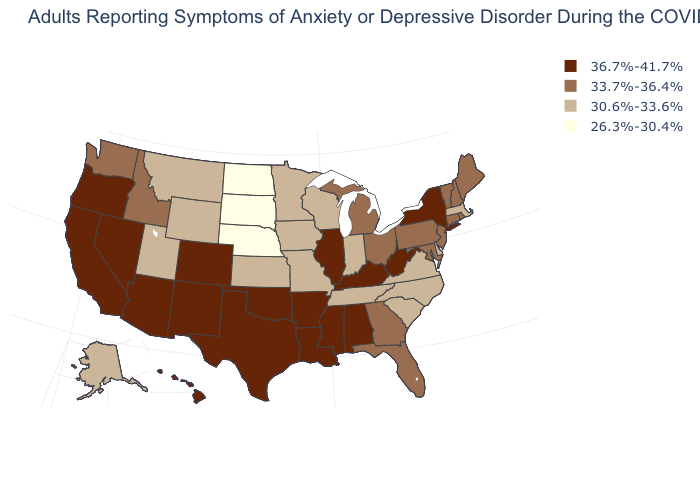What is the lowest value in states that border Massachusetts?
Be succinct. 33.7%-36.4%. What is the value of Minnesota?
Answer briefly. 30.6%-33.6%. What is the value of Minnesota?
Quick response, please. 30.6%-33.6%. What is the value of Kentucky?
Keep it brief. 36.7%-41.7%. Name the states that have a value in the range 36.7%-41.7%?
Give a very brief answer. Alabama, Arizona, Arkansas, California, Colorado, Hawaii, Illinois, Kentucky, Louisiana, Mississippi, Nevada, New Mexico, New York, Oklahoma, Oregon, Texas, West Virginia. Among the states that border Alabama , which have the highest value?
Short answer required. Mississippi. Name the states that have a value in the range 33.7%-36.4%?
Quick response, please. Connecticut, Florida, Georgia, Idaho, Maine, Maryland, Michigan, New Hampshire, New Jersey, Ohio, Pennsylvania, Rhode Island, Vermont, Washington. Among the states that border Pennsylvania , which have the highest value?
Quick response, please. New York, West Virginia. Does Utah have the lowest value in the West?
Concise answer only. Yes. Name the states that have a value in the range 36.7%-41.7%?
Quick response, please. Alabama, Arizona, Arkansas, California, Colorado, Hawaii, Illinois, Kentucky, Louisiana, Mississippi, Nevada, New Mexico, New York, Oklahoma, Oregon, Texas, West Virginia. What is the highest value in the South ?
Concise answer only. 36.7%-41.7%. Does Idaho have the same value as Colorado?
Concise answer only. No. Which states have the lowest value in the Northeast?
Give a very brief answer. Massachusetts. Does the first symbol in the legend represent the smallest category?
Write a very short answer. No. Does the first symbol in the legend represent the smallest category?
Write a very short answer. No. 